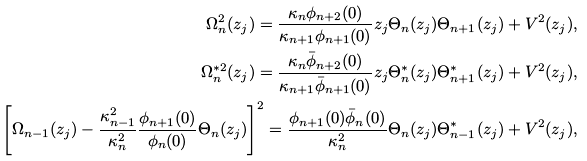<formula> <loc_0><loc_0><loc_500><loc_500>\Omega ^ { 2 } _ { n } ( z _ { j } ) = \frac { \kappa _ { n } \phi _ { n + 2 } ( 0 ) } { \kappa _ { n + 1 } \phi _ { n + 1 } ( 0 ) } z _ { j } \Theta _ { n } ( z _ { j } ) \Theta _ { n + 1 } ( z _ { j } ) + V ^ { 2 } ( z _ { j } ) , \\ \Omega ^ { * 2 } _ { n } ( z _ { j } ) = \frac { \kappa _ { n } \bar { \phi } _ { n + 2 } ( 0 ) } { \kappa _ { n + 1 } \bar { \phi } _ { n + 1 } ( 0 ) } z _ { j } \Theta ^ { * } _ { n } ( z _ { j } ) \Theta ^ { * } _ { n + 1 } ( z _ { j } ) + V ^ { 2 } ( z _ { j } ) , \\ \left [ \Omega _ { n - 1 } ( z _ { j } ) - \frac { \kappa ^ { 2 } _ { n - 1 } } { \kappa ^ { 2 } _ { n } } \frac { \phi _ { n + 1 } ( 0 ) } { \phi _ { n } ( 0 ) } \Theta _ { n } ( z _ { j } ) \right ] ^ { 2 } = \frac { \phi _ { n + 1 } ( 0 ) \bar { \phi } _ { n } ( 0 ) } { \kappa ^ { 2 } _ { n } } \Theta _ { n } ( z _ { j } ) \Theta ^ { * } _ { n - 1 } ( z _ { j } ) + V ^ { 2 } ( z _ { j } ) ,</formula> 